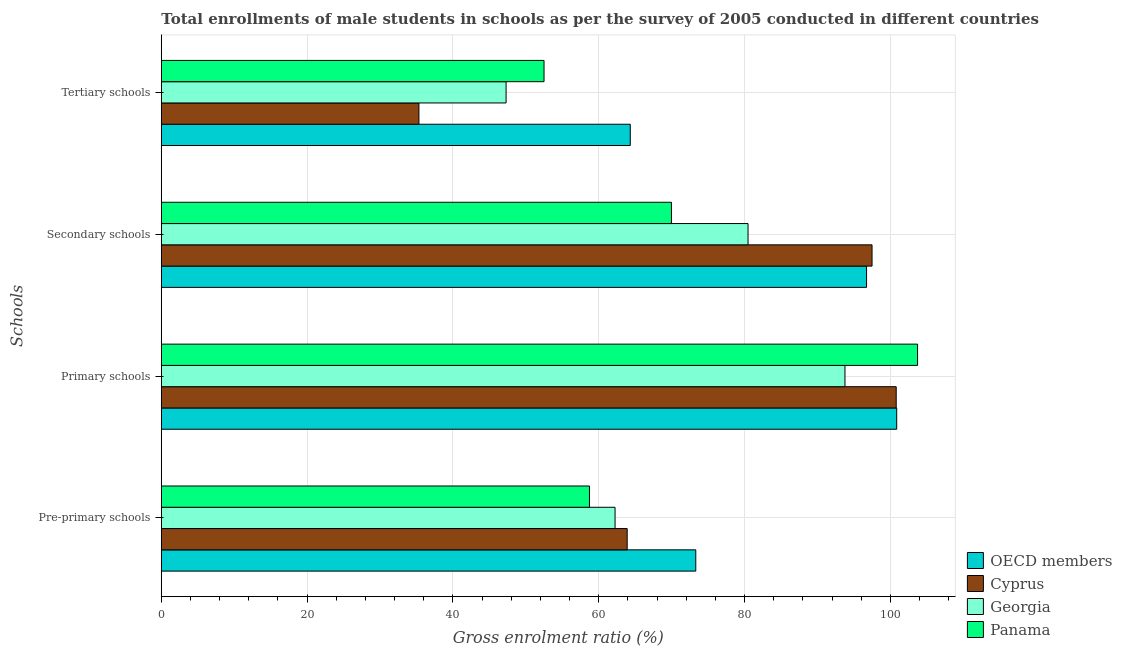Are the number of bars on each tick of the Y-axis equal?
Provide a short and direct response. Yes. How many bars are there on the 2nd tick from the bottom?
Offer a very short reply. 4. What is the label of the 3rd group of bars from the top?
Offer a very short reply. Primary schools. What is the gross enrolment ratio(male) in secondary schools in Georgia?
Offer a very short reply. 80.47. Across all countries, what is the maximum gross enrolment ratio(male) in tertiary schools?
Ensure brevity in your answer.  64.32. Across all countries, what is the minimum gross enrolment ratio(male) in tertiary schools?
Your answer should be very brief. 35.33. In which country was the gross enrolment ratio(male) in tertiary schools maximum?
Ensure brevity in your answer.  OECD members. In which country was the gross enrolment ratio(male) in secondary schools minimum?
Your answer should be very brief. Panama. What is the total gross enrolment ratio(male) in pre-primary schools in the graph?
Offer a very short reply. 258.15. What is the difference between the gross enrolment ratio(male) in primary schools in Georgia and that in OECD members?
Offer a very short reply. -7.1. What is the difference between the gross enrolment ratio(male) in tertiary schools in Cyprus and the gross enrolment ratio(male) in primary schools in Georgia?
Provide a succinct answer. -58.43. What is the average gross enrolment ratio(male) in pre-primary schools per country?
Give a very brief answer. 64.54. What is the difference between the gross enrolment ratio(male) in pre-primary schools and gross enrolment ratio(male) in tertiary schools in Panama?
Keep it short and to the point. 6.23. What is the ratio of the gross enrolment ratio(male) in secondary schools in Panama to that in OECD members?
Give a very brief answer. 0.72. Is the difference between the gross enrolment ratio(male) in tertiary schools in Cyprus and OECD members greater than the difference between the gross enrolment ratio(male) in pre-primary schools in Cyprus and OECD members?
Offer a terse response. No. What is the difference between the highest and the second highest gross enrolment ratio(male) in pre-primary schools?
Offer a very short reply. 9.41. What is the difference between the highest and the lowest gross enrolment ratio(male) in primary schools?
Give a very brief answer. 9.96. What does the 3rd bar from the bottom in Secondary schools represents?
Your response must be concise. Georgia. Is it the case that in every country, the sum of the gross enrolment ratio(male) in pre-primary schools and gross enrolment ratio(male) in primary schools is greater than the gross enrolment ratio(male) in secondary schools?
Your answer should be compact. Yes. How many countries are there in the graph?
Provide a short and direct response. 4. Are the values on the major ticks of X-axis written in scientific E-notation?
Offer a terse response. No. How many legend labels are there?
Your answer should be compact. 4. What is the title of the graph?
Give a very brief answer. Total enrollments of male students in schools as per the survey of 2005 conducted in different countries. What is the label or title of the X-axis?
Keep it short and to the point. Gross enrolment ratio (%). What is the label or title of the Y-axis?
Ensure brevity in your answer.  Schools. What is the Gross enrolment ratio (%) in OECD members in Pre-primary schools?
Provide a succinct answer. 73.3. What is the Gross enrolment ratio (%) in Cyprus in Pre-primary schools?
Give a very brief answer. 63.9. What is the Gross enrolment ratio (%) of Georgia in Pre-primary schools?
Provide a short and direct response. 62.23. What is the Gross enrolment ratio (%) in Panama in Pre-primary schools?
Make the answer very short. 58.72. What is the Gross enrolment ratio (%) of OECD members in Primary schools?
Ensure brevity in your answer.  100.86. What is the Gross enrolment ratio (%) in Cyprus in Primary schools?
Provide a short and direct response. 100.79. What is the Gross enrolment ratio (%) of Georgia in Primary schools?
Offer a very short reply. 93.77. What is the Gross enrolment ratio (%) in Panama in Primary schools?
Provide a short and direct response. 103.72. What is the Gross enrolment ratio (%) in OECD members in Secondary schools?
Provide a short and direct response. 96.73. What is the Gross enrolment ratio (%) in Cyprus in Secondary schools?
Offer a very short reply. 97.48. What is the Gross enrolment ratio (%) of Georgia in Secondary schools?
Provide a short and direct response. 80.47. What is the Gross enrolment ratio (%) in Panama in Secondary schools?
Provide a short and direct response. 69.96. What is the Gross enrolment ratio (%) in OECD members in Tertiary schools?
Your response must be concise. 64.32. What is the Gross enrolment ratio (%) of Cyprus in Tertiary schools?
Give a very brief answer. 35.33. What is the Gross enrolment ratio (%) in Georgia in Tertiary schools?
Your response must be concise. 47.29. What is the Gross enrolment ratio (%) in Panama in Tertiary schools?
Give a very brief answer. 52.49. Across all Schools, what is the maximum Gross enrolment ratio (%) in OECD members?
Make the answer very short. 100.86. Across all Schools, what is the maximum Gross enrolment ratio (%) in Cyprus?
Your response must be concise. 100.79. Across all Schools, what is the maximum Gross enrolment ratio (%) of Georgia?
Offer a terse response. 93.77. Across all Schools, what is the maximum Gross enrolment ratio (%) in Panama?
Provide a succinct answer. 103.72. Across all Schools, what is the minimum Gross enrolment ratio (%) in OECD members?
Make the answer very short. 64.32. Across all Schools, what is the minimum Gross enrolment ratio (%) in Cyprus?
Your answer should be very brief. 35.33. Across all Schools, what is the minimum Gross enrolment ratio (%) of Georgia?
Offer a very short reply. 47.29. Across all Schools, what is the minimum Gross enrolment ratio (%) in Panama?
Offer a terse response. 52.49. What is the total Gross enrolment ratio (%) in OECD members in the graph?
Offer a very short reply. 335.21. What is the total Gross enrolment ratio (%) of Cyprus in the graph?
Offer a very short reply. 297.5. What is the total Gross enrolment ratio (%) of Georgia in the graph?
Give a very brief answer. 283.76. What is the total Gross enrolment ratio (%) in Panama in the graph?
Offer a very short reply. 284.9. What is the difference between the Gross enrolment ratio (%) of OECD members in Pre-primary schools and that in Primary schools?
Keep it short and to the point. -27.56. What is the difference between the Gross enrolment ratio (%) in Cyprus in Pre-primary schools and that in Primary schools?
Provide a succinct answer. -36.9. What is the difference between the Gross enrolment ratio (%) in Georgia in Pre-primary schools and that in Primary schools?
Provide a succinct answer. -31.53. What is the difference between the Gross enrolment ratio (%) of Panama in Pre-primary schools and that in Primary schools?
Make the answer very short. -45. What is the difference between the Gross enrolment ratio (%) in OECD members in Pre-primary schools and that in Secondary schools?
Your answer should be compact. -23.42. What is the difference between the Gross enrolment ratio (%) in Cyprus in Pre-primary schools and that in Secondary schools?
Your response must be concise. -33.58. What is the difference between the Gross enrolment ratio (%) in Georgia in Pre-primary schools and that in Secondary schools?
Provide a short and direct response. -18.24. What is the difference between the Gross enrolment ratio (%) of Panama in Pre-primary schools and that in Secondary schools?
Provide a succinct answer. -11.24. What is the difference between the Gross enrolment ratio (%) of OECD members in Pre-primary schools and that in Tertiary schools?
Keep it short and to the point. 8.99. What is the difference between the Gross enrolment ratio (%) of Cyprus in Pre-primary schools and that in Tertiary schools?
Offer a very short reply. 28.57. What is the difference between the Gross enrolment ratio (%) in Georgia in Pre-primary schools and that in Tertiary schools?
Offer a terse response. 14.95. What is the difference between the Gross enrolment ratio (%) of Panama in Pre-primary schools and that in Tertiary schools?
Your response must be concise. 6.23. What is the difference between the Gross enrolment ratio (%) of OECD members in Primary schools and that in Secondary schools?
Provide a succinct answer. 4.13. What is the difference between the Gross enrolment ratio (%) of Cyprus in Primary schools and that in Secondary schools?
Ensure brevity in your answer.  3.31. What is the difference between the Gross enrolment ratio (%) in Georgia in Primary schools and that in Secondary schools?
Keep it short and to the point. 13.29. What is the difference between the Gross enrolment ratio (%) in Panama in Primary schools and that in Secondary schools?
Your answer should be very brief. 33.76. What is the difference between the Gross enrolment ratio (%) in OECD members in Primary schools and that in Tertiary schools?
Make the answer very short. 36.54. What is the difference between the Gross enrolment ratio (%) of Cyprus in Primary schools and that in Tertiary schools?
Ensure brevity in your answer.  65.46. What is the difference between the Gross enrolment ratio (%) in Georgia in Primary schools and that in Tertiary schools?
Offer a terse response. 46.48. What is the difference between the Gross enrolment ratio (%) of Panama in Primary schools and that in Tertiary schools?
Your response must be concise. 51.23. What is the difference between the Gross enrolment ratio (%) of OECD members in Secondary schools and that in Tertiary schools?
Give a very brief answer. 32.41. What is the difference between the Gross enrolment ratio (%) of Cyprus in Secondary schools and that in Tertiary schools?
Ensure brevity in your answer.  62.15. What is the difference between the Gross enrolment ratio (%) in Georgia in Secondary schools and that in Tertiary schools?
Offer a terse response. 33.18. What is the difference between the Gross enrolment ratio (%) of Panama in Secondary schools and that in Tertiary schools?
Provide a short and direct response. 17.48. What is the difference between the Gross enrolment ratio (%) of OECD members in Pre-primary schools and the Gross enrolment ratio (%) of Cyprus in Primary schools?
Ensure brevity in your answer.  -27.49. What is the difference between the Gross enrolment ratio (%) in OECD members in Pre-primary schools and the Gross enrolment ratio (%) in Georgia in Primary schools?
Provide a short and direct response. -20.46. What is the difference between the Gross enrolment ratio (%) of OECD members in Pre-primary schools and the Gross enrolment ratio (%) of Panama in Primary schools?
Your response must be concise. -30.42. What is the difference between the Gross enrolment ratio (%) of Cyprus in Pre-primary schools and the Gross enrolment ratio (%) of Georgia in Primary schools?
Offer a very short reply. -29.87. What is the difference between the Gross enrolment ratio (%) in Cyprus in Pre-primary schools and the Gross enrolment ratio (%) in Panama in Primary schools?
Offer a terse response. -39.83. What is the difference between the Gross enrolment ratio (%) of Georgia in Pre-primary schools and the Gross enrolment ratio (%) of Panama in Primary schools?
Make the answer very short. -41.49. What is the difference between the Gross enrolment ratio (%) of OECD members in Pre-primary schools and the Gross enrolment ratio (%) of Cyprus in Secondary schools?
Provide a succinct answer. -24.18. What is the difference between the Gross enrolment ratio (%) in OECD members in Pre-primary schools and the Gross enrolment ratio (%) in Georgia in Secondary schools?
Your response must be concise. -7.17. What is the difference between the Gross enrolment ratio (%) in OECD members in Pre-primary schools and the Gross enrolment ratio (%) in Panama in Secondary schools?
Give a very brief answer. 3.34. What is the difference between the Gross enrolment ratio (%) of Cyprus in Pre-primary schools and the Gross enrolment ratio (%) of Georgia in Secondary schools?
Ensure brevity in your answer.  -16.57. What is the difference between the Gross enrolment ratio (%) in Cyprus in Pre-primary schools and the Gross enrolment ratio (%) in Panama in Secondary schools?
Provide a succinct answer. -6.07. What is the difference between the Gross enrolment ratio (%) in Georgia in Pre-primary schools and the Gross enrolment ratio (%) in Panama in Secondary schools?
Keep it short and to the point. -7.73. What is the difference between the Gross enrolment ratio (%) of OECD members in Pre-primary schools and the Gross enrolment ratio (%) of Cyprus in Tertiary schools?
Provide a succinct answer. 37.97. What is the difference between the Gross enrolment ratio (%) in OECD members in Pre-primary schools and the Gross enrolment ratio (%) in Georgia in Tertiary schools?
Provide a short and direct response. 26.02. What is the difference between the Gross enrolment ratio (%) in OECD members in Pre-primary schools and the Gross enrolment ratio (%) in Panama in Tertiary schools?
Offer a terse response. 20.81. What is the difference between the Gross enrolment ratio (%) in Cyprus in Pre-primary schools and the Gross enrolment ratio (%) in Georgia in Tertiary schools?
Keep it short and to the point. 16.61. What is the difference between the Gross enrolment ratio (%) in Cyprus in Pre-primary schools and the Gross enrolment ratio (%) in Panama in Tertiary schools?
Offer a very short reply. 11.41. What is the difference between the Gross enrolment ratio (%) in Georgia in Pre-primary schools and the Gross enrolment ratio (%) in Panama in Tertiary schools?
Ensure brevity in your answer.  9.74. What is the difference between the Gross enrolment ratio (%) of OECD members in Primary schools and the Gross enrolment ratio (%) of Cyprus in Secondary schools?
Ensure brevity in your answer.  3.38. What is the difference between the Gross enrolment ratio (%) in OECD members in Primary schools and the Gross enrolment ratio (%) in Georgia in Secondary schools?
Offer a very short reply. 20.39. What is the difference between the Gross enrolment ratio (%) in OECD members in Primary schools and the Gross enrolment ratio (%) in Panama in Secondary schools?
Give a very brief answer. 30.9. What is the difference between the Gross enrolment ratio (%) of Cyprus in Primary schools and the Gross enrolment ratio (%) of Georgia in Secondary schools?
Your answer should be very brief. 20.32. What is the difference between the Gross enrolment ratio (%) in Cyprus in Primary schools and the Gross enrolment ratio (%) in Panama in Secondary schools?
Ensure brevity in your answer.  30.83. What is the difference between the Gross enrolment ratio (%) of Georgia in Primary schools and the Gross enrolment ratio (%) of Panama in Secondary schools?
Provide a succinct answer. 23.8. What is the difference between the Gross enrolment ratio (%) in OECD members in Primary schools and the Gross enrolment ratio (%) in Cyprus in Tertiary schools?
Your response must be concise. 65.53. What is the difference between the Gross enrolment ratio (%) of OECD members in Primary schools and the Gross enrolment ratio (%) of Georgia in Tertiary schools?
Your response must be concise. 53.57. What is the difference between the Gross enrolment ratio (%) of OECD members in Primary schools and the Gross enrolment ratio (%) of Panama in Tertiary schools?
Your response must be concise. 48.37. What is the difference between the Gross enrolment ratio (%) of Cyprus in Primary schools and the Gross enrolment ratio (%) of Georgia in Tertiary schools?
Your answer should be very brief. 53.5. What is the difference between the Gross enrolment ratio (%) of Cyprus in Primary schools and the Gross enrolment ratio (%) of Panama in Tertiary schools?
Give a very brief answer. 48.3. What is the difference between the Gross enrolment ratio (%) of Georgia in Primary schools and the Gross enrolment ratio (%) of Panama in Tertiary schools?
Give a very brief answer. 41.28. What is the difference between the Gross enrolment ratio (%) of OECD members in Secondary schools and the Gross enrolment ratio (%) of Cyprus in Tertiary schools?
Your answer should be compact. 61.4. What is the difference between the Gross enrolment ratio (%) of OECD members in Secondary schools and the Gross enrolment ratio (%) of Georgia in Tertiary schools?
Keep it short and to the point. 49.44. What is the difference between the Gross enrolment ratio (%) of OECD members in Secondary schools and the Gross enrolment ratio (%) of Panama in Tertiary schools?
Give a very brief answer. 44.24. What is the difference between the Gross enrolment ratio (%) in Cyprus in Secondary schools and the Gross enrolment ratio (%) in Georgia in Tertiary schools?
Keep it short and to the point. 50.19. What is the difference between the Gross enrolment ratio (%) of Cyprus in Secondary schools and the Gross enrolment ratio (%) of Panama in Tertiary schools?
Your answer should be very brief. 44.99. What is the difference between the Gross enrolment ratio (%) in Georgia in Secondary schools and the Gross enrolment ratio (%) in Panama in Tertiary schools?
Offer a very short reply. 27.98. What is the average Gross enrolment ratio (%) in OECD members per Schools?
Your answer should be very brief. 83.8. What is the average Gross enrolment ratio (%) of Cyprus per Schools?
Ensure brevity in your answer.  74.37. What is the average Gross enrolment ratio (%) of Georgia per Schools?
Your response must be concise. 70.94. What is the average Gross enrolment ratio (%) in Panama per Schools?
Offer a terse response. 71.22. What is the difference between the Gross enrolment ratio (%) of OECD members and Gross enrolment ratio (%) of Cyprus in Pre-primary schools?
Offer a terse response. 9.41. What is the difference between the Gross enrolment ratio (%) in OECD members and Gross enrolment ratio (%) in Georgia in Pre-primary schools?
Offer a terse response. 11.07. What is the difference between the Gross enrolment ratio (%) of OECD members and Gross enrolment ratio (%) of Panama in Pre-primary schools?
Your answer should be compact. 14.58. What is the difference between the Gross enrolment ratio (%) in Cyprus and Gross enrolment ratio (%) in Georgia in Pre-primary schools?
Your answer should be compact. 1.66. What is the difference between the Gross enrolment ratio (%) of Cyprus and Gross enrolment ratio (%) of Panama in Pre-primary schools?
Your answer should be compact. 5.17. What is the difference between the Gross enrolment ratio (%) of Georgia and Gross enrolment ratio (%) of Panama in Pre-primary schools?
Make the answer very short. 3.51. What is the difference between the Gross enrolment ratio (%) of OECD members and Gross enrolment ratio (%) of Cyprus in Primary schools?
Provide a short and direct response. 0.07. What is the difference between the Gross enrolment ratio (%) of OECD members and Gross enrolment ratio (%) of Georgia in Primary schools?
Your answer should be compact. 7.1. What is the difference between the Gross enrolment ratio (%) of OECD members and Gross enrolment ratio (%) of Panama in Primary schools?
Ensure brevity in your answer.  -2.86. What is the difference between the Gross enrolment ratio (%) in Cyprus and Gross enrolment ratio (%) in Georgia in Primary schools?
Your response must be concise. 7.03. What is the difference between the Gross enrolment ratio (%) of Cyprus and Gross enrolment ratio (%) of Panama in Primary schools?
Your response must be concise. -2.93. What is the difference between the Gross enrolment ratio (%) in Georgia and Gross enrolment ratio (%) in Panama in Primary schools?
Keep it short and to the point. -9.96. What is the difference between the Gross enrolment ratio (%) in OECD members and Gross enrolment ratio (%) in Cyprus in Secondary schools?
Give a very brief answer. -0.75. What is the difference between the Gross enrolment ratio (%) of OECD members and Gross enrolment ratio (%) of Georgia in Secondary schools?
Give a very brief answer. 16.26. What is the difference between the Gross enrolment ratio (%) of OECD members and Gross enrolment ratio (%) of Panama in Secondary schools?
Make the answer very short. 26.76. What is the difference between the Gross enrolment ratio (%) in Cyprus and Gross enrolment ratio (%) in Georgia in Secondary schools?
Offer a very short reply. 17.01. What is the difference between the Gross enrolment ratio (%) of Cyprus and Gross enrolment ratio (%) of Panama in Secondary schools?
Make the answer very short. 27.51. What is the difference between the Gross enrolment ratio (%) of Georgia and Gross enrolment ratio (%) of Panama in Secondary schools?
Provide a short and direct response. 10.51. What is the difference between the Gross enrolment ratio (%) in OECD members and Gross enrolment ratio (%) in Cyprus in Tertiary schools?
Your answer should be compact. 28.99. What is the difference between the Gross enrolment ratio (%) of OECD members and Gross enrolment ratio (%) of Georgia in Tertiary schools?
Provide a short and direct response. 17.03. What is the difference between the Gross enrolment ratio (%) of OECD members and Gross enrolment ratio (%) of Panama in Tertiary schools?
Offer a very short reply. 11.83. What is the difference between the Gross enrolment ratio (%) in Cyprus and Gross enrolment ratio (%) in Georgia in Tertiary schools?
Give a very brief answer. -11.96. What is the difference between the Gross enrolment ratio (%) in Cyprus and Gross enrolment ratio (%) in Panama in Tertiary schools?
Keep it short and to the point. -17.16. What is the difference between the Gross enrolment ratio (%) in Georgia and Gross enrolment ratio (%) in Panama in Tertiary schools?
Make the answer very short. -5.2. What is the ratio of the Gross enrolment ratio (%) in OECD members in Pre-primary schools to that in Primary schools?
Ensure brevity in your answer.  0.73. What is the ratio of the Gross enrolment ratio (%) of Cyprus in Pre-primary schools to that in Primary schools?
Give a very brief answer. 0.63. What is the ratio of the Gross enrolment ratio (%) in Georgia in Pre-primary schools to that in Primary schools?
Offer a terse response. 0.66. What is the ratio of the Gross enrolment ratio (%) of Panama in Pre-primary schools to that in Primary schools?
Your answer should be very brief. 0.57. What is the ratio of the Gross enrolment ratio (%) in OECD members in Pre-primary schools to that in Secondary schools?
Offer a very short reply. 0.76. What is the ratio of the Gross enrolment ratio (%) in Cyprus in Pre-primary schools to that in Secondary schools?
Your answer should be very brief. 0.66. What is the ratio of the Gross enrolment ratio (%) of Georgia in Pre-primary schools to that in Secondary schools?
Your response must be concise. 0.77. What is the ratio of the Gross enrolment ratio (%) in Panama in Pre-primary schools to that in Secondary schools?
Provide a succinct answer. 0.84. What is the ratio of the Gross enrolment ratio (%) in OECD members in Pre-primary schools to that in Tertiary schools?
Your answer should be very brief. 1.14. What is the ratio of the Gross enrolment ratio (%) of Cyprus in Pre-primary schools to that in Tertiary schools?
Offer a very short reply. 1.81. What is the ratio of the Gross enrolment ratio (%) in Georgia in Pre-primary schools to that in Tertiary schools?
Offer a very short reply. 1.32. What is the ratio of the Gross enrolment ratio (%) of Panama in Pre-primary schools to that in Tertiary schools?
Ensure brevity in your answer.  1.12. What is the ratio of the Gross enrolment ratio (%) in OECD members in Primary schools to that in Secondary schools?
Your answer should be very brief. 1.04. What is the ratio of the Gross enrolment ratio (%) in Cyprus in Primary schools to that in Secondary schools?
Ensure brevity in your answer.  1.03. What is the ratio of the Gross enrolment ratio (%) of Georgia in Primary schools to that in Secondary schools?
Provide a succinct answer. 1.17. What is the ratio of the Gross enrolment ratio (%) of Panama in Primary schools to that in Secondary schools?
Keep it short and to the point. 1.48. What is the ratio of the Gross enrolment ratio (%) in OECD members in Primary schools to that in Tertiary schools?
Provide a succinct answer. 1.57. What is the ratio of the Gross enrolment ratio (%) in Cyprus in Primary schools to that in Tertiary schools?
Keep it short and to the point. 2.85. What is the ratio of the Gross enrolment ratio (%) in Georgia in Primary schools to that in Tertiary schools?
Offer a terse response. 1.98. What is the ratio of the Gross enrolment ratio (%) in Panama in Primary schools to that in Tertiary schools?
Offer a very short reply. 1.98. What is the ratio of the Gross enrolment ratio (%) in OECD members in Secondary schools to that in Tertiary schools?
Ensure brevity in your answer.  1.5. What is the ratio of the Gross enrolment ratio (%) of Cyprus in Secondary schools to that in Tertiary schools?
Your answer should be compact. 2.76. What is the ratio of the Gross enrolment ratio (%) in Georgia in Secondary schools to that in Tertiary schools?
Your answer should be compact. 1.7. What is the ratio of the Gross enrolment ratio (%) in Panama in Secondary schools to that in Tertiary schools?
Provide a short and direct response. 1.33. What is the difference between the highest and the second highest Gross enrolment ratio (%) in OECD members?
Offer a terse response. 4.13. What is the difference between the highest and the second highest Gross enrolment ratio (%) of Cyprus?
Provide a succinct answer. 3.31. What is the difference between the highest and the second highest Gross enrolment ratio (%) of Georgia?
Give a very brief answer. 13.29. What is the difference between the highest and the second highest Gross enrolment ratio (%) in Panama?
Make the answer very short. 33.76. What is the difference between the highest and the lowest Gross enrolment ratio (%) of OECD members?
Offer a terse response. 36.54. What is the difference between the highest and the lowest Gross enrolment ratio (%) of Cyprus?
Your answer should be compact. 65.46. What is the difference between the highest and the lowest Gross enrolment ratio (%) in Georgia?
Offer a very short reply. 46.48. What is the difference between the highest and the lowest Gross enrolment ratio (%) in Panama?
Offer a very short reply. 51.23. 